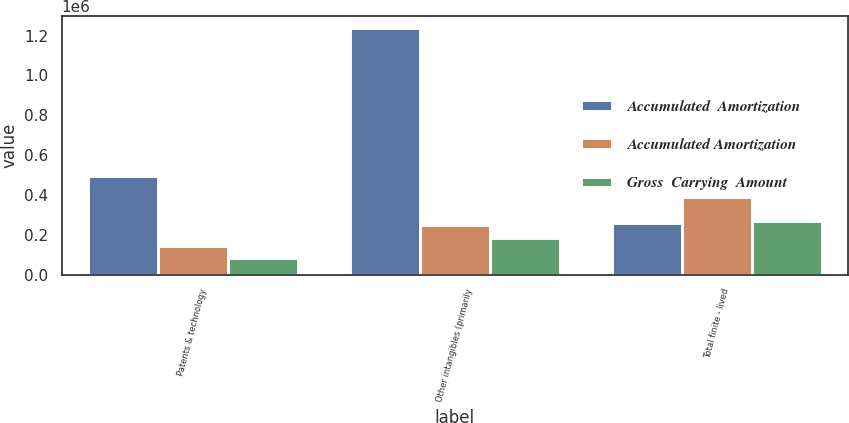<chart> <loc_0><loc_0><loc_500><loc_500><stacked_bar_chart><ecel><fcel>Patents & technology<fcel>Other intangibles (primarily<fcel>Total finite - lived<nl><fcel>Accumulated  Amortization<fcel>494047<fcel>1.2377e+06<fcel>258883<nl><fcel>Accumulated Amortization<fcel>142850<fcel>247984<fcel>390834<nl><fcel>Gross  Carrying  Amount<fcel>84669<fcel>185113<fcel>269782<nl></chart> 